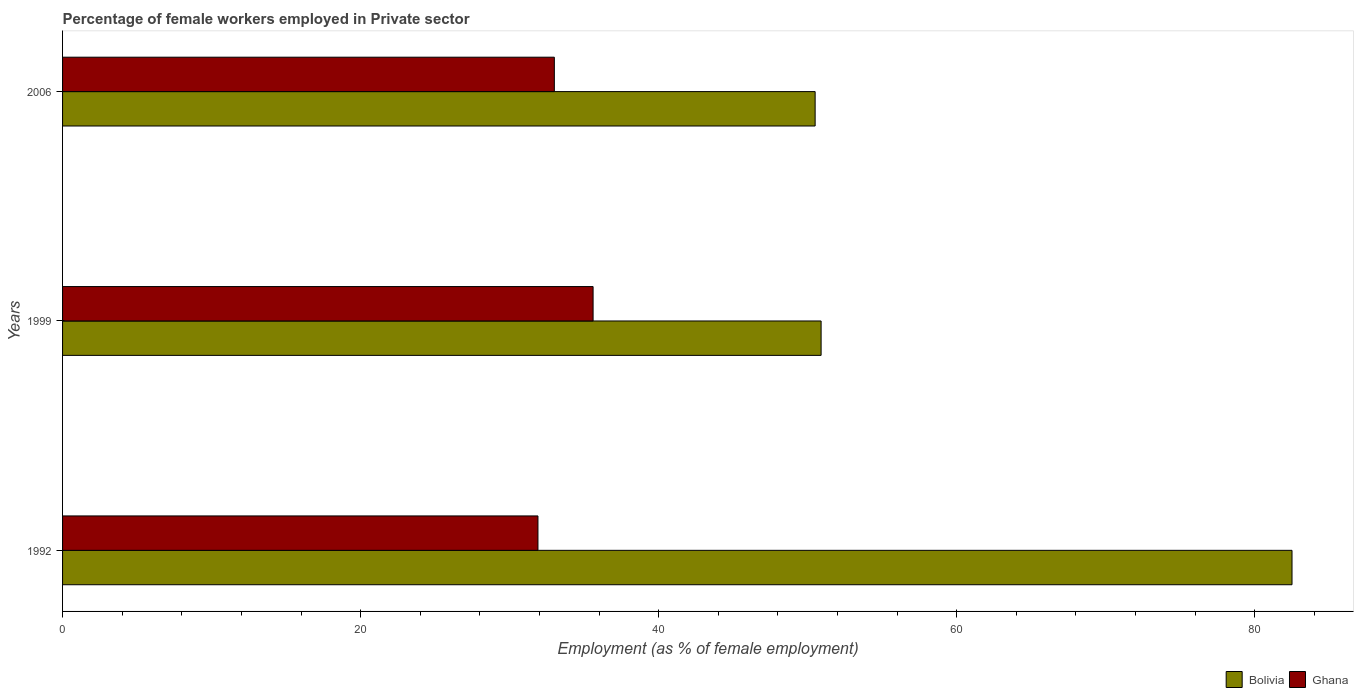How many different coloured bars are there?
Ensure brevity in your answer.  2. Are the number of bars on each tick of the Y-axis equal?
Make the answer very short. Yes. How many bars are there on the 3rd tick from the bottom?
Make the answer very short. 2. What is the label of the 1st group of bars from the top?
Keep it short and to the point. 2006. What is the percentage of females employed in Private sector in Bolivia in 1992?
Your response must be concise. 82.5. Across all years, what is the maximum percentage of females employed in Private sector in Bolivia?
Offer a terse response. 82.5. Across all years, what is the minimum percentage of females employed in Private sector in Ghana?
Ensure brevity in your answer.  31.9. What is the total percentage of females employed in Private sector in Bolivia in the graph?
Ensure brevity in your answer.  183.9. What is the difference between the percentage of females employed in Private sector in Bolivia in 1992 and that in 1999?
Your answer should be compact. 31.6. What is the difference between the percentage of females employed in Private sector in Ghana in 1992 and the percentage of females employed in Private sector in Bolivia in 1999?
Keep it short and to the point. -19. What is the average percentage of females employed in Private sector in Bolivia per year?
Offer a terse response. 61.3. In the year 1999, what is the difference between the percentage of females employed in Private sector in Bolivia and percentage of females employed in Private sector in Ghana?
Provide a short and direct response. 15.3. In how many years, is the percentage of females employed in Private sector in Bolivia greater than 40 %?
Provide a succinct answer. 3. What is the ratio of the percentage of females employed in Private sector in Ghana in 1992 to that in 2006?
Ensure brevity in your answer.  0.97. Is the percentage of females employed in Private sector in Bolivia in 1999 less than that in 2006?
Make the answer very short. No. Is the difference between the percentage of females employed in Private sector in Bolivia in 1999 and 2006 greater than the difference between the percentage of females employed in Private sector in Ghana in 1999 and 2006?
Offer a very short reply. No. What is the difference between the highest and the second highest percentage of females employed in Private sector in Ghana?
Your response must be concise. 2.6. What is the difference between the highest and the lowest percentage of females employed in Private sector in Ghana?
Provide a succinct answer. 3.7. In how many years, is the percentage of females employed in Private sector in Bolivia greater than the average percentage of females employed in Private sector in Bolivia taken over all years?
Keep it short and to the point. 1. How many bars are there?
Ensure brevity in your answer.  6. How many years are there in the graph?
Your answer should be very brief. 3. What is the difference between two consecutive major ticks on the X-axis?
Your answer should be very brief. 20. Are the values on the major ticks of X-axis written in scientific E-notation?
Offer a very short reply. No. Does the graph contain grids?
Ensure brevity in your answer.  No. Where does the legend appear in the graph?
Provide a succinct answer. Bottom right. How are the legend labels stacked?
Ensure brevity in your answer.  Horizontal. What is the title of the graph?
Make the answer very short. Percentage of female workers employed in Private sector. What is the label or title of the X-axis?
Offer a very short reply. Employment (as % of female employment). What is the label or title of the Y-axis?
Keep it short and to the point. Years. What is the Employment (as % of female employment) in Bolivia in 1992?
Keep it short and to the point. 82.5. What is the Employment (as % of female employment) in Ghana in 1992?
Provide a succinct answer. 31.9. What is the Employment (as % of female employment) of Bolivia in 1999?
Ensure brevity in your answer.  50.9. What is the Employment (as % of female employment) of Ghana in 1999?
Your response must be concise. 35.6. What is the Employment (as % of female employment) in Bolivia in 2006?
Your answer should be compact. 50.5. Across all years, what is the maximum Employment (as % of female employment) in Bolivia?
Offer a terse response. 82.5. Across all years, what is the maximum Employment (as % of female employment) of Ghana?
Your response must be concise. 35.6. Across all years, what is the minimum Employment (as % of female employment) of Bolivia?
Your answer should be compact. 50.5. Across all years, what is the minimum Employment (as % of female employment) of Ghana?
Provide a succinct answer. 31.9. What is the total Employment (as % of female employment) in Bolivia in the graph?
Make the answer very short. 183.9. What is the total Employment (as % of female employment) of Ghana in the graph?
Provide a succinct answer. 100.5. What is the difference between the Employment (as % of female employment) in Bolivia in 1992 and that in 1999?
Give a very brief answer. 31.6. What is the difference between the Employment (as % of female employment) of Bolivia in 1992 and that in 2006?
Offer a terse response. 32. What is the difference between the Employment (as % of female employment) in Bolivia in 1999 and that in 2006?
Ensure brevity in your answer.  0.4. What is the difference between the Employment (as % of female employment) of Bolivia in 1992 and the Employment (as % of female employment) of Ghana in 1999?
Ensure brevity in your answer.  46.9. What is the difference between the Employment (as % of female employment) of Bolivia in 1992 and the Employment (as % of female employment) of Ghana in 2006?
Keep it short and to the point. 49.5. What is the difference between the Employment (as % of female employment) in Bolivia in 1999 and the Employment (as % of female employment) in Ghana in 2006?
Your answer should be compact. 17.9. What is the average Employment (as % of female employment) of Bolivia per year?
Give a very brief answer. 61.3. What is the average Employment (as % of female employment) of Ghana per year?
Your response must be concise. 33.5. In the year 1992, what is the difference between the Employment (as % of female employment) in Bolivia and Employment (as % of female employment) in Ghana?
Keep it short and to the point. 50.6. What is the ratio of the Employment (as % of female employment) in Bolivia in 1992 to that in 1999?
Ensure brevity in your answer.  1.62. What is the ratio of the Employment (as % of female employment) of Ghana in 1992 to that in 1999?
Provide a succinct answer. 0.9. What is the ratio of the Employment (as % of female employment) of Bolivia in 1992 to that in 2006?
Your response must be concise. 1.63. What is the ratio of the Employment (as % of female employment) in Ghana in 1992 to that in 2006?
Your response must be concise. 0.97. What is the ratio of the Employment (as % of female employment) of Bolivia in 1999 to that in 2006?
Ensure brevity in your answer.  1.01. What is the ratio of the Employment (as % of female employment) of Ghana in 1999 to that in 2006?
Make the answer very short. 1.08. What is the difference between the highest and the second highest Employment (as % of female employment) of Bolivia?
Ensure brevity in your answer.  31.6. What is the difference between the highest and the second highest Employment (as % of female employment) of Ghana?
Your answer should be very brief. 2.6. What is the difference between the highest and the lowest Employment (as % of female employment) in Bolivia?
Provide a short and direct response. 32. What is the difference between the highest and the lowest Employment (as % of female employment) of Ghana?
Keep it short and to the point. 3.7. 